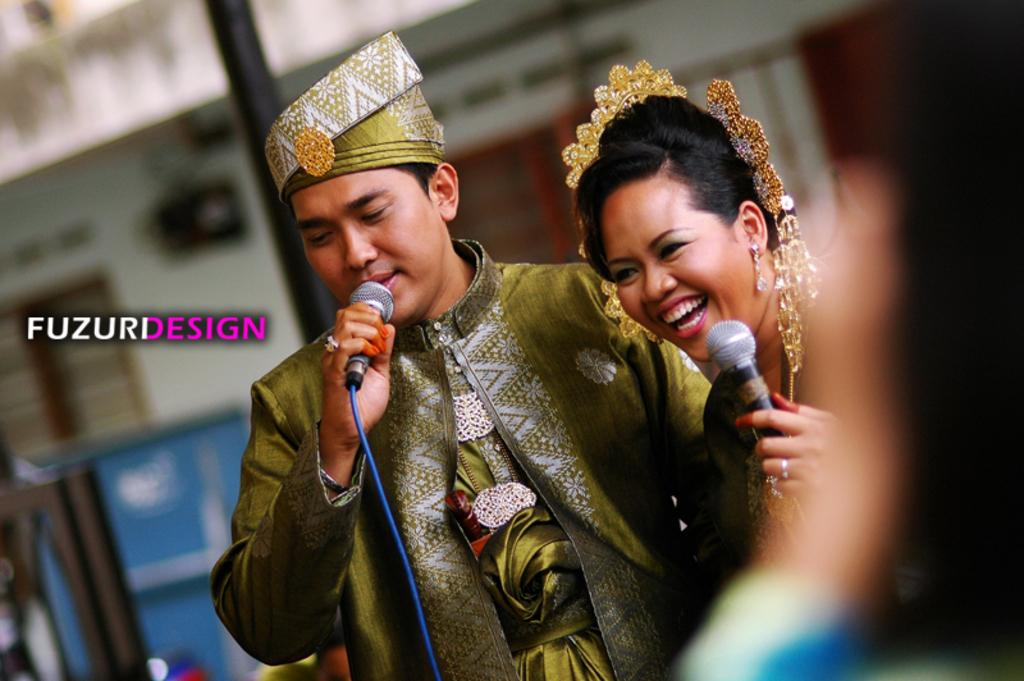What are the two people in the image doing? The well-dressed man and woman are holding mics in the image. What can be inferred about the setting of the image based on the attire of the people? The well-dressed man and woman suggest a formal or professional setting. What is the condition of the background in the image? The background of the image is blurry. What is present in the image that might indicate a specific organization or event? There is a logo in the image. What type of fear is the man expressing in the image? There is no indication of fear in the image; the man and woman are holding mics, which suggests they might be in a professional or performance setting. What is the man using to collect water from the well in the image? There is no well or bucket present in the image; it features a well-dressed man and woman holding mics. 